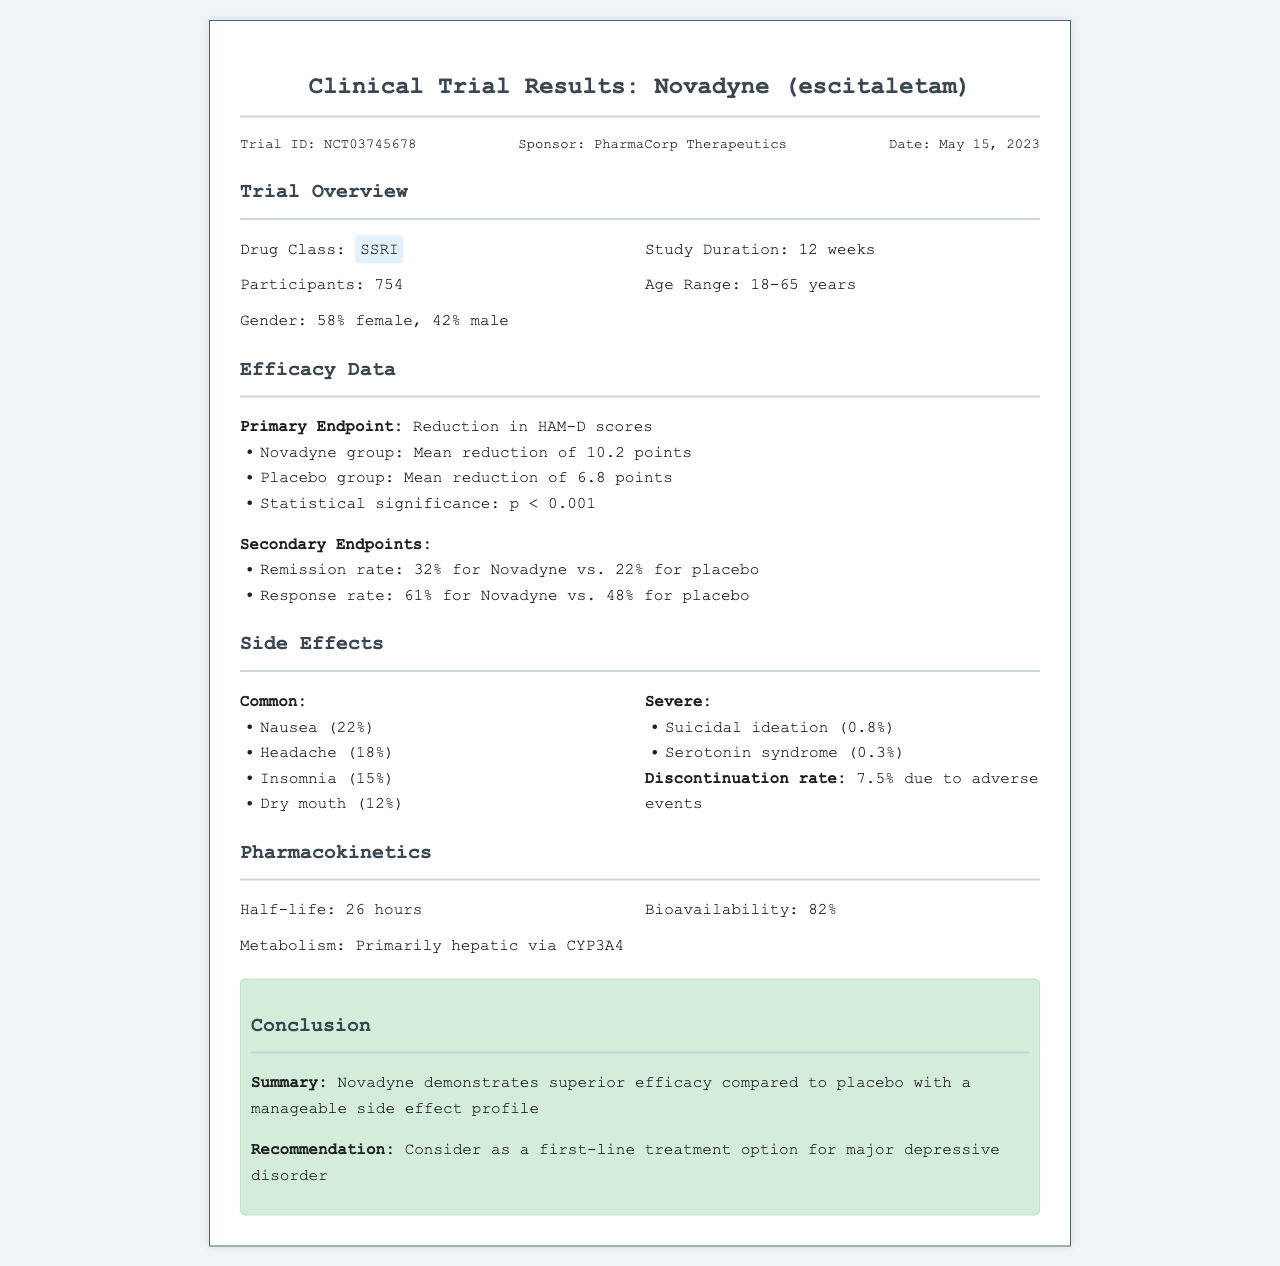What is the trial ID? The trial ID is a specific identifier for the clinical trial in the document.
Answer: NCT03745678 What is the drug class of Novadyne? The drug class is categorized based on its pharmacological effects on the human body.
Answer: SSRI What was the mean reduction in HAM-D scores for Novadyne? This value indicates the primary endpoint effectiveness of the drug in the trial.
Answer: 10.2 points What percentage of participants experienced nausea as a side effect? This figure reflects how common nausea was among trial participants taking Novadyne.
Answer: 22% What is the discontinuation rate due to adverse events? It indicates the percentage of participants who stopped the treatment due to side effects.
Answer: 7.5% What is the recommendation for Novadyne based on the trial results? This phrase summarizes the concluding advice related to the drug's potential use in treatment.
Answer: Consider as a first-line treatment option for major depressive disorder What was the age range of participants in the trial? This information provides insight into the demographics involved in the clinical study.
Answer: 18-65 years What sponsor conducted the clinical trial? The sponsor is the organization responsible for financing and organizing the study.
Answer: PharmaCorp Therapeutics What was the biological availability percentage of Novadyne? This value indicates how much of the drug enters the bloodstream when administered.
Answer: 82% 